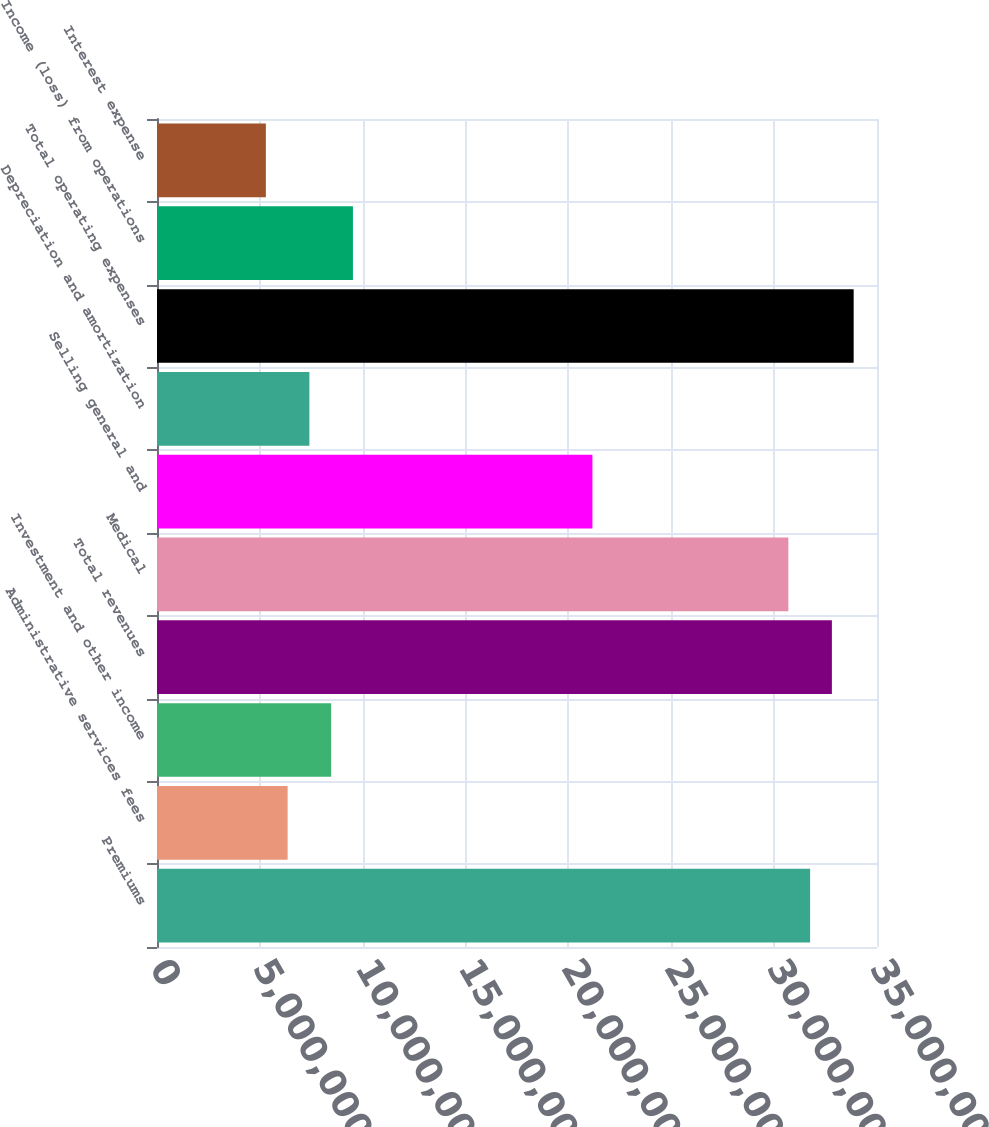Convert chart. <chart><loc_0><loc_0><loc_500><loc_500><bar_chart><fcel>Premiums<fcel>Administrative services fees<fcel>Investment and other income<fcel>Total revenues<fcel>Medical<fcel>Selling general and<fcel>Depreciation and amortization<fcel>Total operating expenses<fcel>Income (loss) from operations<fcel>Interest expense<nl><fcel>3.17489e+07<fcel>6.34979e+06<fcel>8.46639e+06<fcel>3.28072e+07<fcel>3.06906e+07<fcel>2.1166e+07<fcel>7.40809e+06<fcel>3.38655e+07<fcel>9.52468e+06<fcel>5.29149e+06<nl></chart> 